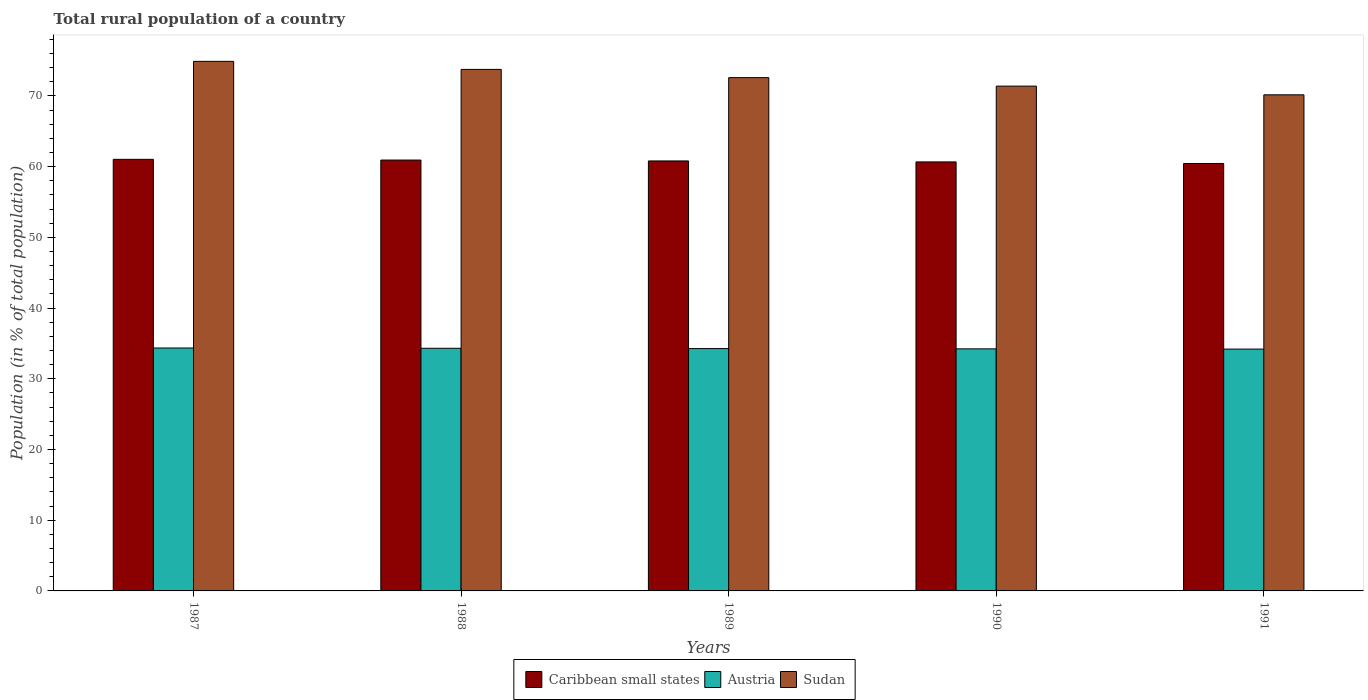How many different coloured bars are there?
Your response must be concise. 3. Are the number of bars per tick equal to the number of legend labels?
Offer a very short reply. Yes. Are the number of bars on each tick of the X-axis equal?
Offer a very short reply. Yes. How many bars are there on the 1st tick from the left?
Give a very brief answer. 3. How many bars are there on the 3rd tick from the right?
Your answer should be very brief. 3. What is the label of the 5th group of bars from the left?
Keep it short and to the point. 1991. In how many cases, is the number of bars for a given year not equal to the number of legend labels?
Your answer should be compact. 0. What is the rural population in Sudan in 1988?
Your answer should be compact. 73.76. Across all years, what is the maximum rural population in Caribbean small states?
Ensure brevity in your answer.  61.04. Across all years, what is the minimum rural population in Caribbean small states?
Give a very brief answer. 60.45. What is the total rural population in Caribbean small states in the graph?
Offer a very short reply. 303.9. What is the difference between the rural population in Austria in 1990 and that in 1991?
Provide a succinct answer. 0.03. What is the difference between the rural population in Sudan in 1987 and the rural population in Caribbean small states in 1990?
Your response must be concise. 14.22. What is the average rural population in Sudan per year?
Your answer should be compact. 72.56. In the year 1987, what is the difference between the rural population in Sudan and rural population in Caribbean small states?
Make the answer very short. 13.86. In how many years, is the rural population in Sudan greater than 38 %?
Your answer should be very brief. 5. What is the ratio of the rural population in Sudan in 1987 to that in 1991?
Your response must be concise. 1.07. Is the rural population in Sudan in 1989 less than that in 1991?
Provide a short and direct response. No. What is the difference between the highest and the second highest rural population in Sudan?
Your response must be concise. 1.14. What is the difference between the highest and the lowest rural population in Caribbean small states?
Your response must be concise. 0.58. Is the sum of the rural population in Austria in 1987 and 1989 greater than the maximum rural population in Caribbean small states across all years?
Offer a very short reply. Yes. What does the 3rd bar from the left in 1991 represents?
Make the answer very short. Sudan. What does the 1st bar from the right in 1990 represents?
Provide a short and direct response. Sudan. Is it the case that in every year, the sum of the rural population in Caribbean small states and rural population in Sudan is greater than the rural population in Austria?
Keep it short and to the point. Yes. How many bars are there?
Your response must be concise. 15. Are all the bars in the graph horizontal?
Ensure brevity in your answer.  No. How many years are there in the graph?
Keep it short and to the point. 5. Does the graph contain any zero values?
Your answer should be very brief. No. Does the graph contain grids?
Make the answer very short. No. How are the legend labels stacked?
Offer a very short reply. Horizontal. What is the title of the graph?
Provide a succinct answer. Total rural population of a country. Does "Tuvalu" appear as one of the legend labels in the graph?
Ensure brevity in your answer.  No. What is the label or title of the Y-axis?
Offer a terse response. Population (in % of total population). What is the Population (in % of total population) in Caribbean small states in 1987?
Give a very brief answer. 61.04. What is the Population (in % of total population) of Austria in 1987?
Offer a very short reply. 34.35. What is the Population (in % of total population) of Sudan in 1987?
Provide a succinct answer. 74.89. What is the Population (in % of total population) in Caribbean small states in 1988?
Offer a terse response. 60.93. What is the Population (in % of total population) of Austria in 1988?
Your answer should be compact. 34.31. What is the Population (in % of total population) in Sudan in 1988?
Provide a succinct answer. 73.76. What is the Population (in % of total population) of Caribbean small states in 1989?
Offer a terse response. 60.81. What is the Population (in % of total population) of Austria in 1989?
Keep it short and to the point. 34.27. What is the Population (in % of total population) of Sudan in 1989?
Make the answer very short. 72.59. What is the Population (in % of total population) of Caribbean small states in 1990?
Keep it short and to the point. 60.67. What is the Population (in % of total population) in Austria in 1990?
Offer a terse response. 34.23. What is the Population (in % of total population) of Sudan in 1990?
Give a very brief answer. 71.39. What is the Population (in % of total population) of Caribbean small states in 1991?
Make the answer very short. 60.45. What is the Population (in % of total population) of Austria in 1991?
Your answer should be compact. 34.2. What is the Population (in % of total population) of Sudan in 1991?
Give a very brief answer. 70.16. Across all years, what is the maximum Population (in % of total population) of Caribbean small states?
Offer a very short reply. 61.04. Across all years, what is the maximum Population (in % of total population) of Austria?
Offer a very short reply. 34.35. Across all years, what is the maximum Population (in % of total population) in Sudan?
Provide a short and direct response. 74.89. Across all years, what is the minimum Population (in % of total population) of Caribbean small states?
Offer a terse response. 60.45. Across all years, what is the minimum Population (in % of total population) of Austria?
Keep it short and to the point. 34.2. Across all years, what is the minimum Population (in % of total population) in Sudan?
Ensure brevity in your answer.  70.16. What is the total Population (in % of total population) in Caribbean small states in the graph?
Your answer should be compact. 303.9. What is the total Population (in % of total population) of Austria in the graph?
Your answer should be compact. 171.38. What is the total Population (in % of total population) of Sudan in the graph?
Your answer should be compact. 362.79. What is the difference between the Population (in % of total population) in Caribbean small states in 1987 and that in 1988?
Offer a very short reply. 0.1. What is the difference between the Population (in % of total population) in Sudan in 1987 and that in 1988?
Provide a succinct answer. 1.14. What is the difference between the Population (in % of total population) of Caribbean small states in 1987 and that in 1989?
Make the answer very short. 0.23. What is the difference between the Population (in % of total population) of Austria in 1987 and that in 1989?
Make the answer very short. 0.08. What is the difference between the Population (in % of total population) in Sudan in 1987 and that in 1989?
Your answer should be compact. 2.3. What is the difference between the Population (in % of total population) of Caribbean small states in 1987 and that in 1990?
Keep it short and to the point. 0.36. What is the difference between the Population (in % of total population) of Austria in 1987 and that in 1990?
Offer a terse response. 0.12. What is the difference between the Population (in % of total population) of Sudan in 1987 and that in 1990?
Provide a short and direct response. 3.5. What is the difference between the Population (in % of total population) of Caribbean small states in 1987 and that in 1991?
Give a very brief answer. 0.58. What is the difference between the Population (in % of total population) in Austria in 1987 and that in 1991?
Your answer should be compact. 0.15. What is the difference between the Population (in % of total population) of Sudan in 1987 and that in 1991?
Provide a succinct answer. 4.73. What is the difference between the Population (in % of total population) in Caribbean small states in 1988 and that in 1989?
Offer a very short reply. 0.13. What is the difference between the Population (in % of total population) of Austria in 1988 and that in 1989?
Ensure brevity in your answer.  0.04. What is the difference between the Population (in % of total population) of Sudan in 1988 and that in 1989?
Give a very brief answer. 1.17. What is the difference between the Population (in % of total population) of Caribbean small states in 1988 and that in 1990?
Ensure brevity in your answer.  0.26. What is the difference between the Population (in % of total population) of Austria in 1988 and that in 1990?
Your answer should be very brief. 0.08. What is the difference between the Population (in % of total population) of Sudan in 1988 and that in 1990?
Provide a succinct answer. 2.37. What is the difference between the Population (in % of total population) of Caribbean small states in 1988 and that in 1991?
Ensure brevity in your answer.  0.48. What is the difference between the Population (in % of total population) of Austria in 1988 and that in 1991?
Offer a terse response. 0.11. What is the difference between the Population (in % of total population) in Sudan in 1988 and that in 1991?
Your answer should be compact. 3.6. What is the difference between the Population (in % of total population) of Caribbean small states in 1989 and that in 1990?
Ensure brevity in your answer.  0.14. What is the difference between the Population (in % of total population) in Caribbean small states in 1989 and that in 1991?
Give a very brief answer. 0.36. What is the difference between the Population (in % of total population) of Austria in 1989 and that in 1991?
Your answer should be very brief. 0.07. What is the difference between the Population (in % of total population) of Sudan in 1989 and that in 1991?
Your response must be concise. 2.43. What is the difference between the Population (in % of total population) in Caribbean small states in 1990 and that in 1991?
Provide a short and direct response. 0.22. What is the difference between the Population (in % of total population) in Austria in 1990 and that in 1991?
Provide a succinct answer. 0.04. What is the difference between the Population (in % of total population) in Sudan in 1990 and that in 1991?
Your answer should be very brief. 1.23. What is the difference between the Population (in % of total population) of Caribbean small states in 1987 and the Population (in % of total population) of Austria in 1988?
Offer a very short reply. 26.72. What is the difference between the Population (in % of total population) of Caribbean small states in 1987 and the Population (in % of total population) of Sudan in 1988?
Your answer should be very brief. -12.72. What is the difference between the Population (in % of total population) in Austria in 1987 and the Population (in % of total population) in Sudan in 1988?
Your answer should be compact. -39.4. What is the difference between the Population (in % of total population) of Caribbean small states in 1987 and the Population (in % of total population) of Austria in 1989?
Your answer should be compact. 26.76. What is the difference between the Population (in % of total population) in Caribbean small states in 1987 and the Population (in % of total population) in Sudan in 1989?
Provide a short and direct response. -11.55. What is the difference between the Population (in % of total population) in Austria in 1987 and the Population (in % of total population) in Sudan in 1989?
Give a very brief answer. -38.24. What is the difference between the Population (in % of total population) in Caribbean small states in 1987 and the Population (in % of total population) in Austria in 1990?
Provide a succinct answer. 26.8. What is the difference between the Population (in % of total population) in Caribbean small states in 1987 and the Population (in % of total population) in Sudan in 1990?
Provide a short and direct response. -10.35. What is the difference between the Population (in % of total population) of Austria in 1987 and the Population (in % of total population) of Sudan in 1990?
Make the answer very short. -37.04. What is the difference between the Population (in % of total population) of Caribbean small states in 1987 and the Population (in % of total population) of Austria in 1991?
Offer a very short reply. 26.84. What is the difference between the Population (in % of total population) of Caribbean small states in 1987 and the Population (in % of total population) of Sudan in 1991?
Your response must be concise. -9.12. What is the difference between the Population (in % of total population) of Austria in 1987 and the Population (in % of total population) of Sudan in 1991?
Offer a terse response. -35.81. What is the difference between the Population (in % of total population) in Caribbean small states in 1988 and the Population (in % of total population) in Austria in 1989?
Keep it short and to the point. 26.66. What is the difference between the Population (in % of total population) in Caribbean small states in 1988 and the Population (in % of total population) in Sudan in 1989?
Keep it short and to the point. -11.66. What is the difference between the Population (in % of total population) of Austria in 1988 and the Population (in % of total population) of Sudan in 1989?
Ensure brevity in your answer.  -38.28. What is the difference between the Population (in % of total population) in Caribbean small states in 1988 and the Population (in % of total population) in Austria in 1990?
Provide a succinct answer. 26.7. What is the difference between the Population (in % of total population) in Caribbean small states in 1988 and the Population (in % of total population) in Sudan in 1990?
Provide a short and direct response. -10.46. What is the difference between the Population (in % of total population) of Austria in 1988 and the Population (in % of total population) of Sudan in 1990?
Your response must be concise. -37.08. What is the difference between the Population (in % of total population) of Caribbean small states in 1988 and the Population (in % of total population) of Austria in 1991?
Your response must be concise. 26.73. What is the difference between the Population (in % of total population) in Caribbean small states in 1988 and the Population (in % of total population) in Sudan in 1991?
Provide a succinct answer. -9.23. What is the difference between the Population (in % of total population) of Austria in 1988 and the Population (in % of total population) of Sudan in 1991?
Offer a very short reply. -35.85. What is the difference between the Population (in % of total population) in Caribbean small states in 1989 and the Population (in % of total population) in Austria in 1990?
Ensure brevity in your answer.  26.57. What is the difference between the Population (in % of total population) of Caribbean small states in 1989 and the Population (in % of total population) of Sudan in 1990?
Provide a succinct answer. -10.58. What is the difference between the Population (in % of total population) in Austria in 1989 and the Population (in % of total population) in Sudan in 1990?
Make the answer very short. -37.12. What is the difference between the Population (in % of total population) of Caribbean small states in 1989 and the Population (in % of total population) of Austria in 1991?
Provide a succinct answer. 26.61. What is the difference between the Population (in % of total population) in Caribbean small states in 1989 and the Population (in % of total population) in Sudan in 1991?
Provide a succinct answer. -9.35. What is the difference between the Population (in % of total population) in Austria in 1989 and the Population (in % of total population) in Sudan in 1991?
Give a very brief answer. -35.88. What is the difference between the Population (in % of total population) in Caribbean small states in 1990 and the Population (in % of total population) in Austria in 1991?
Provide a short and direct response. 26.47. What is the difference between the Population (in % of total population) in Caribbean small states in 1990 and the Population (in % of total population) in Sudan in 1991?
Make the answer very short. -9.49. What is the difference between the Population (in % of total population) of Austria in 1990 and the Population (in % of total population) of Sudan in 1991?
Provide a short and direct response. -35.92. What is the average Population (in % of total population) of Caribbean small states per year?
Provide a short and direct response. 60.78. What is the average Population (in % of total population) of Austria per year?
Your answer should be compact. 34.28. What is the average Population (in % of total population) of Sudan per year?
Offer a very short reply. 72.56. In the year 1987, what is the difference between the Population (in % of total population) in Caribbean small states and Population (in % of total population) in Austria?
Make the answer very short. 26.68. In the year 1987, what is the difference between the Population (in % of total population) of Caribbean small states and Population (in % of total population) of Sudan?
Your answer should be compact. -13.86. In the year 1987, what is the difference between the Population (in % of total population) of Austria and Population (in % of total population) of Sudan?
Offer a terse response. -40.54. In the year 1988, what is the difference between the Population (in % of total population) in Caribbean small states and Population (in % of total population) in Austria?
Make the answer very short. 26.62. In the year 1988, what is the difference between the Population (in % of total population) of Caribbean small states and Population (in % of total population) of Sudan?
Offer a terse response. -12.82. In the year 1988, what is the difference between the Population (in % of total population) in Austria and Population (in % of total population) in Sudan?
Your answer should be very brief. -39.44. In the year 1989, what is the difference between the Population (in % of total population) of Caribbean small states and Population (in % of total population) of Austria?
Keep it short and to the point. 26.53. In the year 1989, what is the difference between the Population (in % of total population) of Caribbean small states and Population (in % of total population) of Sudan?
Offer a terse response. -11.78. In the year 1989, what is the difference between the Population (in % of total population) in Austria and Population (in % of total population) in Sudan?
Make the answer very short. -38.31. In the year 1990, what is the difference between the Population (in % of total population) in Caribbean small states and Population (in % of total population) in Austria?
Offer a terse response. 26.44. In the year 1990, what is the difference between the Population (in % of total population) of Caribbean small states and Population (in % of total population) of Sudan?
Provide a succinct answer. -10.72. In the year 1990, what is the difference between the Population (in % of total population) in Austria and Population (in % of total population) in Sudan?
Offer a terse response. -37.16. In the year 1991, what is the difference between the Population (in % of total population) of Caribbean small states and Population (in % of total population) of Austria?
Provide a short and direct response. 26.25. In the year 1991, what is the difference between the Population (in % of total population) of Caribbean small states and Population (in % of total population) of Sudan?
Provide a succinct answer. -9.71. In the year 1991, what is the difference between the Population (in % of total population) of Austria and Population (in % of total population) of Sudan?
Your answer should be compact. -35.96. What is the ratio of the Population (in % of total population) in Sudan in 1987 to that in 1988?
Provide a succinct answer. 1.02. What is the ratio of the Population (in % of total population) of Sudan in 1987 to that in 1989?
Your answer should be very brief. 1.03. What is the ratio of the Population (in % of total population) in Caribbean small states in 1987 to that in 1990?
Offer a very short reply. 1.01. What is the ratio of the Population (in % of total population) in Austria in 1987 to that in 1990?
Ensure brevity in your answer.  1. What is the ratio of the Population (in % of total population) in Sudan in 1987 to that in 1990?
Offer a very short reply. 1.05. What is the ratio of the Population (in % of total population) in Caribbean small states in 1987 to that in 1991?
Your answer should be very brief. 1.01. What is the ratio of the Population (in % of total population) in Sudan in 1987 to that in 1991?
Keep it short and to the point. 1.07. What is the ratio of the Population (in % of total population) of Caribbean small states in 1988 to that in 1989?
Your answer should be very brief. 1. What is the ratio of the Population (in % of total population) of Sudan in 1988 to that in 1989?
Ensure brevity in your answer.  1.02. What is the ratio of the Population (in % of total population) of Caribbean small states in 1988 to that in 1990?
Offer a very short reply. 1. What is the ratio of the Population (in % of total population) in Sudan in 1988 to that in 1990?
Provide a short and direct response. 1.03. What is the ratio of the Population (in % of total population) in Austria in 1988 to that in 1991?
Make the answer very short. 1. What is the ratio of the Population (in % of total population) of Sudan in 1988 to that in 1991?
Ensure brevity in your answer.  1.05. What is the ratio of the Population (in % of total population) in Caribbean small states in 1989 to that in 1990?
Offer a very short reply. 1. What is the ratio of the Population (in % of total population) of Sudan in 1989 to that in 1990?
Make the answer very short. 1.02. What is the ratio of the Population (in % of total population) in Caribbean small states in 1989 to that in 1991?
Provide a succinct answer. 1.01. What is the ratio of the Population (in % of total population) in Austria in 1989 to that in 1991?
Provide a short and direct response. 1. What is the ratio of the Population (in % of total population) in Sudan in 1989 to that in 1991?
Provide a succinct answer. 1.03. What is the ratio of the Population (in % of total population) in Austria in 1990 to that in 1991?
Ensure brevity in your answer.  1. What is the ratio of the Population (in % of total population) of Sudan in 1990 to that in 1991?
Give a very brief answer. 1.02. What is the difference between the highest and the second highest Population (in % of total population) of Caribbean small states?
Offer a terse response. 0.1. What is the difference between the highest and the second highest Population (in % of total population) in Sudan?
Make the answer very short. 1.14. What is the difference between the highest and the lowest Population (in % of total population) of Caribbean small states?
Ensure brevity in your answer.  0.58. What is the difference between the highest and the lowest Population (in % of total population) in Austria?
Provide a short and direct response. 0.15. What is the difference between the highest and the lowest Population (in % of total population) in Sudan?
Ensure brevity in your answer.  4.73. 